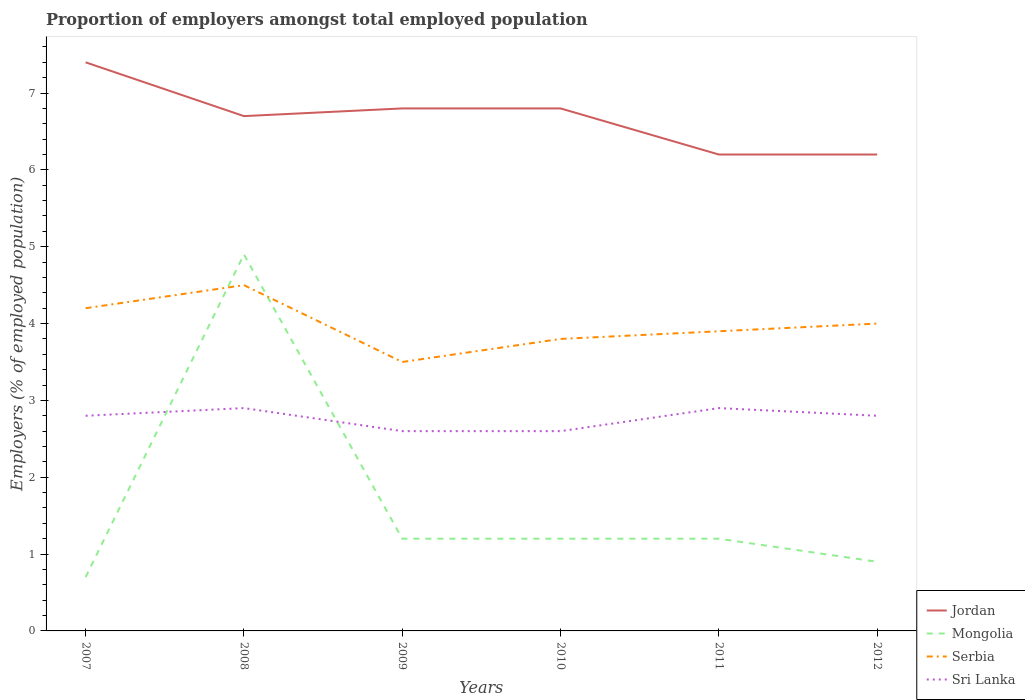Does the line corresponding to Jordan intersect with the line corresponding to Mongolia?
Offer a terse response. No. Is the number of lines equal to the number of legend labels?
Offer a very short reply. Yes. Across all years, what is the maximum proportion of employers in Mongolia?
Provide a short and direct response. 0.7. In which year was the proportion of employers in Serbia maximum?
Provide a succinct answer. 2009. What is the total proportion of employers in Mongolia in the graph?
Provide a short and direct response. 0.3. What is the difference between the highest and the second highest proportion of employers in Sri Lanka?
Offer a very short reply. 0.3. Is the proportion of employers in Mongolia strictly greater than the proportion of employers in Sri Lanka over the years?
Your answer should be very brief. No. How many lines are there?
Ensure brevity in your answer.  4. How many years are there in the graph?
Your answer should be very brief. 6. What is the difference between two consecutive major ticks on the Y-axis?
Your answer should be compact. 1. Are the values on the major ticks of Y-axis written in scientific E-notation?
Your response must be concise. No. Does the graph contain any zero values?
Your answer should be compact. No. How many legend labels are there?
Provide a short and direct response. 4. How are the legend labels stacked?
Make the answer very short. Vertical. What is the title of the graph?
Your response must be concise. Proportion of employers amongst total employed population. Does "North America" appear as one of the legend labels in the graph?
Your response must be concise. No. What is the label or title of the Y-axis?
Provide a short and direct response. Employers (% of employed population). What is the Employers (% of employed population) in Jordan in 2007?
Offer a terse response. 7.4. What is the Employers (% of employed population) in Mongolia in 2007?
Your answer should be very brief. 0.7. What is the Employers (% of employed population) of Serbia in 2007?
Offer a very short reply. 4.2. What is the Employers (% of employed population) in Sri Lanka in 2007?
Your answer should be compact. 2.8. What is the Employers (% of employed population) of Jordan in 2008?
Provide a short and direct response. 6.7. What is the Employers (% of employed population) of Mongolia in 2008?
Provide a short and direct response. 4.9. What is the Employers (% of employed population) in Sri Lanka in 2008?
Make the answer very short. 2.9. What is the Employers (% of employed population) in Jordan in 2009?
Your answer should be compact. 6.8. What is the Employers (% of employed population) of Mongolia in 2009?
Make the answer very short. 1.2. What is the Employers (% of employed population) of Sri Lanka in 2009?
Your answer should be compact. 2.6. What is the Employers (% of employed population) of Jordan in 2010?
Provide a succinct answer. 6.8. What is the Employers (% of employed population) of Mongolia in 2010?
Your response must be concise. 1.2. What is the Employers (% of employed population) in Serbia in 2010?
Offer a very short reply. 3.8. What is the Employers (% of employed population) of Sri Lanka in 2010?
Provide a short and direct response. 2.6. What is the Employers (% of employed population) of Jordan in 2011?
Offer a terse response. 6.2. What is the Employers (% of employed population) in Mongolia in 2011?
Offer a very short reply. 1.2. What is the Employers (% of employed population) of Serbia in 2011?
Offer a terse response. 3.9. What is the Employers (% of employed population) of Sri Lanka in 2011?
Your response must be concise. 2.9. What is the Employers (% of employed population) in Jordan in 2012?
Give a very brief answer. 6.2. What is the Employers (% of employed population) in Mongolia in 2012?
Provide a short and direct response. 0.9. What is the Employers (% of employed population) in Serbia in 2012?
Provide a succinct answer. 4. What is the Employers (% of employed population) in Sri Lanka in 2012?
Provide a succinct answer. 2.8. Across all years, what is the maximum Employers (% of employed population) in Jordan?
Offer a very short reply. 7.4. Across all years, what is the maximum Employers (% of employed population) of Mongolia?
Your response must be concise. 4.9. Across all years, what is the maximum Employers (% of employed population) of Serbia?
Make the answer very short. 4.5. Across all years, what is the maximum Employers (% of employed population) of Sri Lanka?
Give a very brief answer. 2.9. Across all years, what is the minimum Employers (% of employed population) in Jordan?
Your answer should be compact. 6.2. Across all years, what is the minimum Employers (% of employed population) in Mongolia?
Give a very brief answer. 0.7. Across all years, what is the minimum Employers (% of employed population) in Sri Lanka?
Your response must be concise. 2.6. What is the total Employers (% of employed population) of Jordan in the graph?
Your response must be concise. 40.1. What is the total Employers (% of employed population) in Mongolia in the graph?
Provide a succinct answer. 10.1. What is the total Employers (% of employed population) in Serbia in the graph?
Offer a very short reply. 23.9. What is the total Employers (% of employed population) in Sri Lanka in the graph?
Ensure brevity in your answer.  16.6. What is the difference between the Employers (% of employed population) of Jordan in 2007 and that in 2008?
Your answer should be very brief. 0.7. What is the difference between the Employers (% of employed population) in Mongolia in 2007 and that in 2008?
Your answer should be very brief. -4.2. What is the difference between the Employers (% of employed population) of Serbia in 2007 and that in 2008?
Keep it short and to the point. -0.3. What is the difference between the Employers (% of employed population) of Jordan in 2007 and that in 2009?
Offer a very short reply. 0.6. What is the difference between the Employers (% of employed population) in Mongolia in 2007 and that in 2009?
Keep it short and to the point. -0.5. What is the difference between the Employers (% of employed population) in Mongolia in 2007 and that in 2010?
Ensure brevity in your answer.  -0.5. What is the difference between the Employers (% of employed population) in Serbia in 2007 and that in 2010?
Ensure brevity in your answer.  0.4. What is the difference between the Employers (% of employed population) of Sri Lanka in 2007 and that in 2010?
Offer a very short reply. 0.2. What is the difference between the Employers (% of employed population) in Jordan in 2007 and that in 2011?
Provide a short and direct response. 1.2. What is the difference between the Employers (% of employed population) in Mongolia in 2007 and that in 2011?
Offer a very short reply. -0.5. What is the difference between the Employers (% of employed population) of Serbia in 2007 and that in 2011?
Your answer should be compact. 0.3. What is the difference between the Employers (% of employed population) in Sri Lanka in 2007 and that in 2011?
Your answer should be compact. -0.1. What is the difference between the Employers (% of employed population) in Jordan in 2007 and that in 2012?
Ensure brevity in your answer.  1.2. What is the difference between the Employers (% of employed population) of Jordan in 2008 and that in 2009?
Ensure brevity in your answer.  -0.1. What is the difference between the Employers (% of employed population) of Jordan in 2008 and that in 2010?
Give a very brief answer. -0.1. What is the difference between the Employers (% of employed population) of Mongolia in 2008 and that in 2010?
Your answer should be very brief. 3.7. What is the difference between the Employers (% of employed population) in Serbia in 2008 and that in 2010?
Make the answer very short. 0.7. What is the difference between the Employers (% of employed population) of Sri Lanka in 2008 and that in 2010?
Keep it short and to the point. 0.3. What is the difference between the Employers (% of employed population) in Mongolia in 2008 and that in 2011?
Your answer should be compact. 3.7. What is the difference between the Employers (% of employed population) in Mongolia in 2008 and that in 2012?
Make the answer very short. 4. What is the difference between the Employers (% of employed population) in Sri Lanka in 2008 and that in 2012?
Offer a very short reply. 0.1. What is the difference between the Employers (% of employed population) in Jordan in 2009 and that in 2010?
Your response must be concise. 0. What is the difference between the Employers (% of employed population) in Mongolia in 2009 and that in 2010?
Keep it short and to the point. 0. What is the difference between the Employers (% of employed population) in Sri Lanka in 2009 and that in 2010?
Keep it short and to the point. 0. What is the difference between the Employers (% of employed population) of Jordan in 2009 and that in 2011?
Give a very brief answer. 0.6. What is the difference between the Employers (% of employed population) in Mongolia in 2009 and that in 2011?
Your response must be concise. 0. What is the difference between the Employers (% of employed population) in Sri Lanka in 2009 and that in 2011?
Provide a short and direct response. -0.3. What is the difference between the Employers (% of employed population) in Jordan in 2009 and that in 2012?
Your response must be concise. 0.6. What is the difference between the Employers (% of employed population) in Mongolia in 2009 and that in 2012?
Your response must be concise. 0.3. What is the difference between the Employers (% of employed population) of Sri Lanka in 2009 and that in 2012?
Your answer should be very brief. -0.2. What is the difference between the Employers (% of employed population) of Jordan in 2010 and that in 2011?
Give a very brief answer. 0.6. What is the difference between the Employers (% of employed population) in Serbia in 2010 and that in 2011?
Offer a terse response. -0.1. What is the difference between the Employers (% of employed population) of Serbia in 2010 and that in 2012?
Your answer should be compact. -0.2. What is the difference between the Employers (% of employed population) in Jordan in 2011 and that in 2012?
Your answer should be very brief. 0. What is the difference between the Employers (% of employed population) of Mongolia in 2011 and that in 2012?
Your answer should be very brief. 0.3. What is the difference between the Employers (% of employed population) in Jordan in 2007 and the Employers (% of employed population) in Sri Lanka in 2008?
Your answer should be compact. 4.5. What is the difference between the Employers (% of employed population) of Mongolia in 2007 and the Employers (% of employed population) of Sri Lanka in 2008?
Offer a terse response. -2.2. What is the difference between the Employers (% of employed population) in Serbia in 2007 and the Employers (% of employed population) in Sri Lanka in 2008?
Give a very brief answer. 1.3. What is the difference between the Employers (% of employed population) in Jordan in 2007 and the Employers (% of employed population) in Sri Lanka in 2009?
Make the answer very short. 4.8. What is the difference between the Employers (% of employed population) in Mongolia in 2007 and the Employers (% of employed population) in Serbia in 2009?
Give a very brief answer. -2.8. What is the difference between the Employers (% of employed population) of Mongolia in 2007 and the Employers (% of employed population) of Sri Lanka in 2009?
Provide a short and direct response. -1.9. What is the difference between the Employers (% of employed population) of Jordan in 2007 and the Employers (% of employed population) of Mongolia in 2010?
Keep it short and to the point. 6.2. What is the difference between the Employers (% of employed population) of Jordan in 2007 and the Employers (% of employed population) of Sri Lanka in 2010?
Offer a very short reply. 4.8. What is the difference between the Employers (% of employed population) of Mongolia in 2007 and the Employers (% of employed population) of Serbia in 2010?
Make the answer very short. -3.1. What is the difference between the Employers (% of employed population) of Mongolia in 2007 and the Employers (% of employed population) of Serbia in 2011?
Make the answer very short. -3.2. What is the difference between the Employers (% of employed population) in Mongolia in 2007 and the Employers (% of employed population) in Sri Lanka in 2011?
Offer a very short reply. -2.2. What is the difference between the Employers (% of employed population) of Jordan in 2007 and the Employers (% of employed population) of Serbia in 2012?
Your answer should be very brief. 3.4. What is the difference between the Employers (% of employed population) in Jordan in 2007 and the Employers (% of employed population) in Sri Lanka in 2012?
Offer a very short reply. 4.6. What is the difference between the Employers (% of employed population) of Jordan in 2008 and the Employers (% of employed population) of Mongolia in 2009?
Your answer should be very brief. 5.5. What is the difference between the Employers (% of employed population) in Mongolia in 2008 and the Employers (% of employed population) in Serbia in 2009?
Provide a short and direct response. 1.4. What is the difference between the Employers (% of employed population) of Mongolia in 2008 and the Employers (% of employed population) of Sri Lanka in 2009?
Offer a very short reply. 2.3. What is the difference between the Employers (% of employed population) of Jordan in 2008 and the Employers (% of employed population) of Serbia in 2010?
Your answer should be compact. 2.9. What is the difference between the Employers (% of employed population) of Mongolia in 2008 and the Employers (% of employed population) of Serbia in 2010?
Keep it short and to the point. 1.1. What is the difference between the Employers (% of employed population) in Jordan in 2008 and the Employers (% of employed population) in Mongolia in 2011?
Give a very brief answer. 5.5. What is the difference between the Employers (% of employed population) in Jordan in 2008 and the Employers (% of employed population) in Sri Lanka in 2011?
Your answer should be compact. 3.8. What is the difference between the Employers (% of employed population) of Mongolia in 2008 and the Employers (% of employed population) of Serbia in 2011?
Give a very brief answer. 1. What is the difference between the Employers (% of employed population) in Jordan in 2008 and the Employers (% of employed population) in Serbia in 2012?
Offer a very short reply. 2.7. What is the difference between the Employers (% of employed population) in Serbia in 2008 and the Employers (% of employed population) in Sri Lanka in 2012?
Provide a short and direct response. 1.7. What is the difference between the Employers (% of employed population) in Jordan in 2009 and the Employers (% of employed population) in Mongolia in 2010?
Keep it short and to the point. 5.6. What is the difference between the Employers (% of employed population) of Jordan in 2009 and the Employers (% of employed population) of Serbia in 2010?
Offer a terse response. 3. What is the difference between the Employers (% of employed population) of Mongolia in 2009 and the Employers (% of employed population) of Serbia in 2010?
Your answer should be very brief. -2.6. What is the difference between the Employers (% of employed population) of Mongolia in 2009 and the Employers (% of employed population) of Sri Lanka in 2010?
Your response must be concise. -1.4. What is the difference between the Employers (% of employed population) of Serbia in 2009 and the Employers (% of employed population) of Sri Lanka in 2010?
Provide a succinct answer. 0.9. What is the difference between the Employers (% of employed population) in Jordan in 2009 and the Employers (% of employed population) in Serbia in 2011?
Offer a very short reply. 2.9. What is the difference between the Employers (% of employed population) in Jordan in 2009 and the Employers (% of employed population) in Sri Lanka in 2011?
Keep it short and to the point. 3.9. What is the difference between the Employers (% of employed population) in Mongolia in 2009 and the Employers (% of employed population) in Serbia in 2011?
Offer a very short reply. -2.7. What is the difference between the Employers (% of employed population) in Mongolia in 2009 and the Employers (% of employed population) in Sri Lanka in 2011?
Provide a short and direct response. -1.7. What is the difference between the Employers (% of employed population) of Jordan in 2009 and the Employers (% of employed population) of Mongolia in 2012?
Offer a very short reply. 5.9. What is the difference between the Employers (% of employed population) of Jordan in 2009 and the Employers (% of employed population) of Serbia in 2012?
Provide a short and direct response. 2.8. What is the difference between the Employers (% of employed population) in Jordan in 2010 and the Employers (% of employed population) in Sri Lanka in 2011?
Your answer should be compact. 3.9. What is the difference between the Employers (% of employed population) in Mongolia in 2010 and the Employers (% of employed population) in Serbia in 2011?
Provide a succinct answer. -2.7. What is the difference between the Employers (% of employed population) in Serbia in 2010 and the Employers (% of employed population) in Sri Lanka in 2011?
Your answer should be very brief. 0.9. What is the difference between the Employers (% of employed population) of Jordan in 2010 and the Employers (% of employed population) of Mongolia in 2012?
Provide a short and direct response. 5.9. What is the difference between the Employers (% of employed population) in Jordan in 2010 and the Employers (% of employed population) in Serbia in 2012?
Your answer should be compact. 2.8. What is the difference between the Employers (% of employed population) in Mongolia in 2010 and the Employers (% of employed population) in Serbia in 2012?
Your answer should be compact. -2.8. What is the difference between the Employers (% of employed population) of Serbia in 2010 and the Employers (% of employed population) of Sri Lanka in 2012?
Offer a terse response. 1. What is the difference between the Employers (% of employed population) of Mongolia in 2011 and the Employers (% of employed population) of Serbia in 2012?
Provide a succinct answer. -2.8. What is the difference between the Employers (% of employed population) in Mongolia in 2011 and the Employers (% of employed population) in Sri Lanka in 2012?
Your answer should be compact. -1.6. What is the average Employers (% of employed population) in Jordan per year?
Your response must be concise. 6.68. What is the average Employers (% of employed population) of Mongolia per year?
Make the answer very short. 1.68. What is the average Employers (% of employed population) of Serbia per year?
Offer a very short reply. 3.98. What is the average Employers (% of employed population) in Sri Lanka per year?
Make the answer very short. 2.77. In the year 2007, what is the difference between the Employers (% of employed population) in Jordan and Employers (% of employed population) in Sri Lanka?
Your answer should be very brief. 4.6. In the year 2007, what is the difference between the Employers (% of employed population) of Serbia and Employers (% of employed population) of Sri Lanka?
Your response must be concise. 1.4. In the year 2008, what is the difference between the Employers (% of employed population) of Jordan and Employers (% of employed population) of Mongolia?
Your answer should be very brief. 1.8. In the year 2008, what is the difference between the Employers (% of employed population) in Jordan and Employers (% of employed population) in Serbia?
Give a very brief answer. 2.2. In the year 2008, what is the difference between the Employers (% of employed population) of Mongolia and Employers (% of employed population) of Serbia?
Give a very brief answer. 0.4. In the year 2008, what is the difference between the Employers (% of employed population) in Mongolia and Employers (% of employed population) in Sri Lanka?
Provide a short and direct response. 2. In the year 2008, what is the difference between the Employers (% of employed population) of Serbia and Employers (% of employed population) of Sri Lanka?
Your answer should be compact. 1.6. In the year 2009, what is the difference between the Employers (% of employed population) of Mongolia and Employers (% of employed population) of Serbia?
Your answer should be very brief. -2.3. In the year 2009, what is the difference between the Employers (% of employed population) in Mongolia and Employers (% of employed population) in Sri Lanka?
Your answer should be very brief. -1.4. In the year 2009, what is the difference between the Employers (% of employed population) of Serbia and Employers (% of employed population) of Sri Lanka?
Your response must be concise. 0.9. In the year 2010, what is the difference between the Employers (% of employed population) in Mongolia and Employers (% of employed population) in Sri Lanka?
Provide a succinct answer. -1.4. In the year 2010, what is the difference between the Employers (% of employed population) in Serbia and Employers (% of employed population) in Sri Lanka?
Keep it short and to the point. 1.2. In the year 2011, what is the difference between the Employers (% of employed population) of Jordan and Employers (% of employed population) of Mongolia?
Your answer should be very brief. 5. In the year 2011, what is the difference between the Employers (% of employed population) of Jordan and Employers (% of employed population) of Serbia?
Make the answer very short. 2.3. In the year 2011, what is the difference between the Employers (% of employed population) in Serbia and Employers (% of employed population) in Sri Lanka?
Your answer should be compact. 1. What is the ratio of the Employers (% of employed population) of Jordan in 2007 to that in 2008?
Provide a short and direct response. 1.1. What is the ratio of the Employers (% of employed population) in Mongolia in 2007 to that in 2008?
Make the answer very short. 0.14. What is the ratio of the Employers (% of employed population) of Sri Lanka in 2007 to that in 2008?
Offer a terse response. 0.97. What is the ratio of the Employers (% of employed population) of Jordan in 2007 to that in 2009?
Offer a terse response. 1.09. What is the ratio of the Employers (% of employed population) in Mongolia in 2007 to that in 2009?
Provide a short and direct response. 0.58. What is the ratio of the Employers (% of employed population) in Jordan in 2007 to that in 2010?
Offer a very short reply. 1.09. What is the ratio of the Employers (% of employed population) of Mongolia in 2007 to that in 2010?
Provide a short and direct response. 0.58. What is the ratio of the Employers (% of employed population) of Serbia in 2007 to that in 2010?
Provide a succinct answer. 1.11. What is the ratio of the Employers (% of employed population) of Sri Lanka in 2007 to that in 2010?
Give a very brief answer. 1.08. What is the ratio of the Employers (% of employed population) of Jordan in 2007 to that in 2011?
Provide a short and direct response. 1.19. What is the ratio of the Employers (% of employed population) in Mongolia in 2007 to that in 2011?
Your answer should be very brief. 0.58. What is the ratio of the Employers (% of employed population) in Serbia in 2007 to that in 2011?
Your answer should be very brief. 1.08. What is the ratio of the Employers (% of employed population) in Sri Lanka in 2007 to that in 2011?
Your answer should be very brief. 0.97. What is the ratio of the Employers (% of employed population) of Jordan in 2007 to that in 2012?
Provide a short and direct response. 1.19. What is the ratio of the Employers (% of employed population) in Mongolia in 2007 to that in 2012?
Your answer should be compact. 0.78. What is the ratio of the Employers (% of employed population) of Serbia in 2007 to that in 2012?
Give a very brief answer. 1.05. What is the ratio of the Employers (% of employed population) of Mongolia in 2008 to that in 2009?
Ensure brevity in your answer.  4.08. What is the ratio of the Employers (% of employed population) of Serbia in 2008 to that in 2009?
Provide a succinct answer. 1.29. What is the ratio of the Employers (% of employed population) of Sri Lanka in 2008 to that in 2009?
Your answer should be very brief. 1.12. What is the ratio of the Employers (% of employed population) of Jordan in 2008 to that in 2010?
Your response must be concise. 0.99. What is the ratio of the Employers (% of employed population) in Mongolia in 2008 to that in 2010?
Make the answer very short. 4.08. What is the ratio of the Employers (% of employed population) of Serbia in 2008 to that in 2010?
Your response must be concise. 1.18. What is the ratio of the Employers (% of employed population) of Sri Lanka in 2008 to that in 2010?
Provide a succinct answer. 1.12. What is the ratio of the Employers (% of employed population) of Jordan in 2008 to that in 2011?
Ensure brevity in your answer.  1.08. What is the ratio of the Employers (% of employed population) in Mongolia in 2008 to that in 2011?
Your answer should be very brief. 4.08. What is the ratio of the Employers (% of employed population) of Serbia in 2008 to that in 2011?
Make the answer very short. 1.15. What is the ratio of the Employers (% of employed population) in Sri Lanka in 2008 to that in 2011?
Keep it short and to the point. 1. What is the ratio of the Employers (% of employed population) of Jordan in 2008 to that in 2012?
Your response must be concise. 1.08. What is the ratio of the Employers (% of employed population) of Mongolia in 2008 to that in 2012?
Your response must be concise. 5.44. What is the ratio of the Employers (% of employed population) of Serbia in 2008 to that in 2012?
Make the answer very short. 1.12. What is the ratio of the Employers (% of employed population) of Sri Lanka in 2008 to that in 2012?
Offer a terse response. 1.04. What is the ratio of the Employers (% of employed population) of Jordan in 2009 to that in 2010?
Offer a terse response. 1. What is the ratio of the Employers (% of employed population) of Mongolia in 2009 to that in 2010?
Keep it short and to the point. 1. What is the ratio of the Employers (% of employed population) of Serbia in 2009 to that in 2010?
Your answer should be compact. 0.92. What is the ratio of the Employers (% of employed population) of Jordan in 2009 to that in 2011?
Keep it short and to the point. 1.1. What is the ratio of the Employers (% of employed population) in Serbia in 2009 to that in 2011?
Your response must be concise. 0.9. What is the ratio of the Employers (% of employed population) of Sri Lanka in 2009 to that in 2011?
Your answer should be compact. 0.9. What is the ratio of the Employers (% of employed population) of Jordan in 2009 to that in 2012?
Offer a very short reply. 1.1. What is the ratio of the Employers (% of employed population) in Mongolia in 2009 to that in 2012?
Give a very brief answer. 1.33. What is the ratio of the Employers (% of employed population) in Sri Lanka in 2009 to that in 2012?
Provide a short and direct response. 0.93. What is the ratio of the Employers (% of employed population) in Jordan in 2010 to that in 2011?
Provide a succinct answer. 1.1. What is the ratio of the Employers (% of employed population) in Mongolia in 2010 to that in 2011?
Offer a terse response. 1. What is the ratio of the Employers (% of employed population) of Serbia in 2010 to that in 2011?
Your response must be concise. 0.97. What is the ratio of the Employers (% of employed population) of Sri Lanka in 2010 to that in 2011?
Give a very brief answer. 0.9. What is the ratio of the Employers (% of employed population) in Jordan in 2010 to that in 2012?
Offer a very short reply. 1.1. What is the ratio of the Employers (% of employed population) of Mongolia in 2010 to that in 2012?
Your answer should be very brief. 1.33. What is the ratio of the Employers (% of employed population) in Jordan in 2011 to that in 2012?
Offer a terse response. 1. What is the ratio of the Employers (% of employed population) in Mongolia in 2011 to that in 2012?
Give a very brief answer. 1.33. What is the ratio of the Employers (% of employed population) of Sri Lanka in 2011 to that in 2012?
Provide a short and direct response. 1.04. What is the difference between the highest and the second highest Employers (% of employed population) of Jordan?
Your response must be concise. 0.6. What is the difference between the highest and the second highest Employers (% of employed population) of Serbia?
Offer a very short reply. 0.3. What is the difference between the highest and the second highest Employers (% of employed population) of Sri Lanka?
Provide a short and direct response. 0. What is the difference between the highest and the lowest Employers (% of employed population) in Jordan?
Offer a terse response. 1.2. 